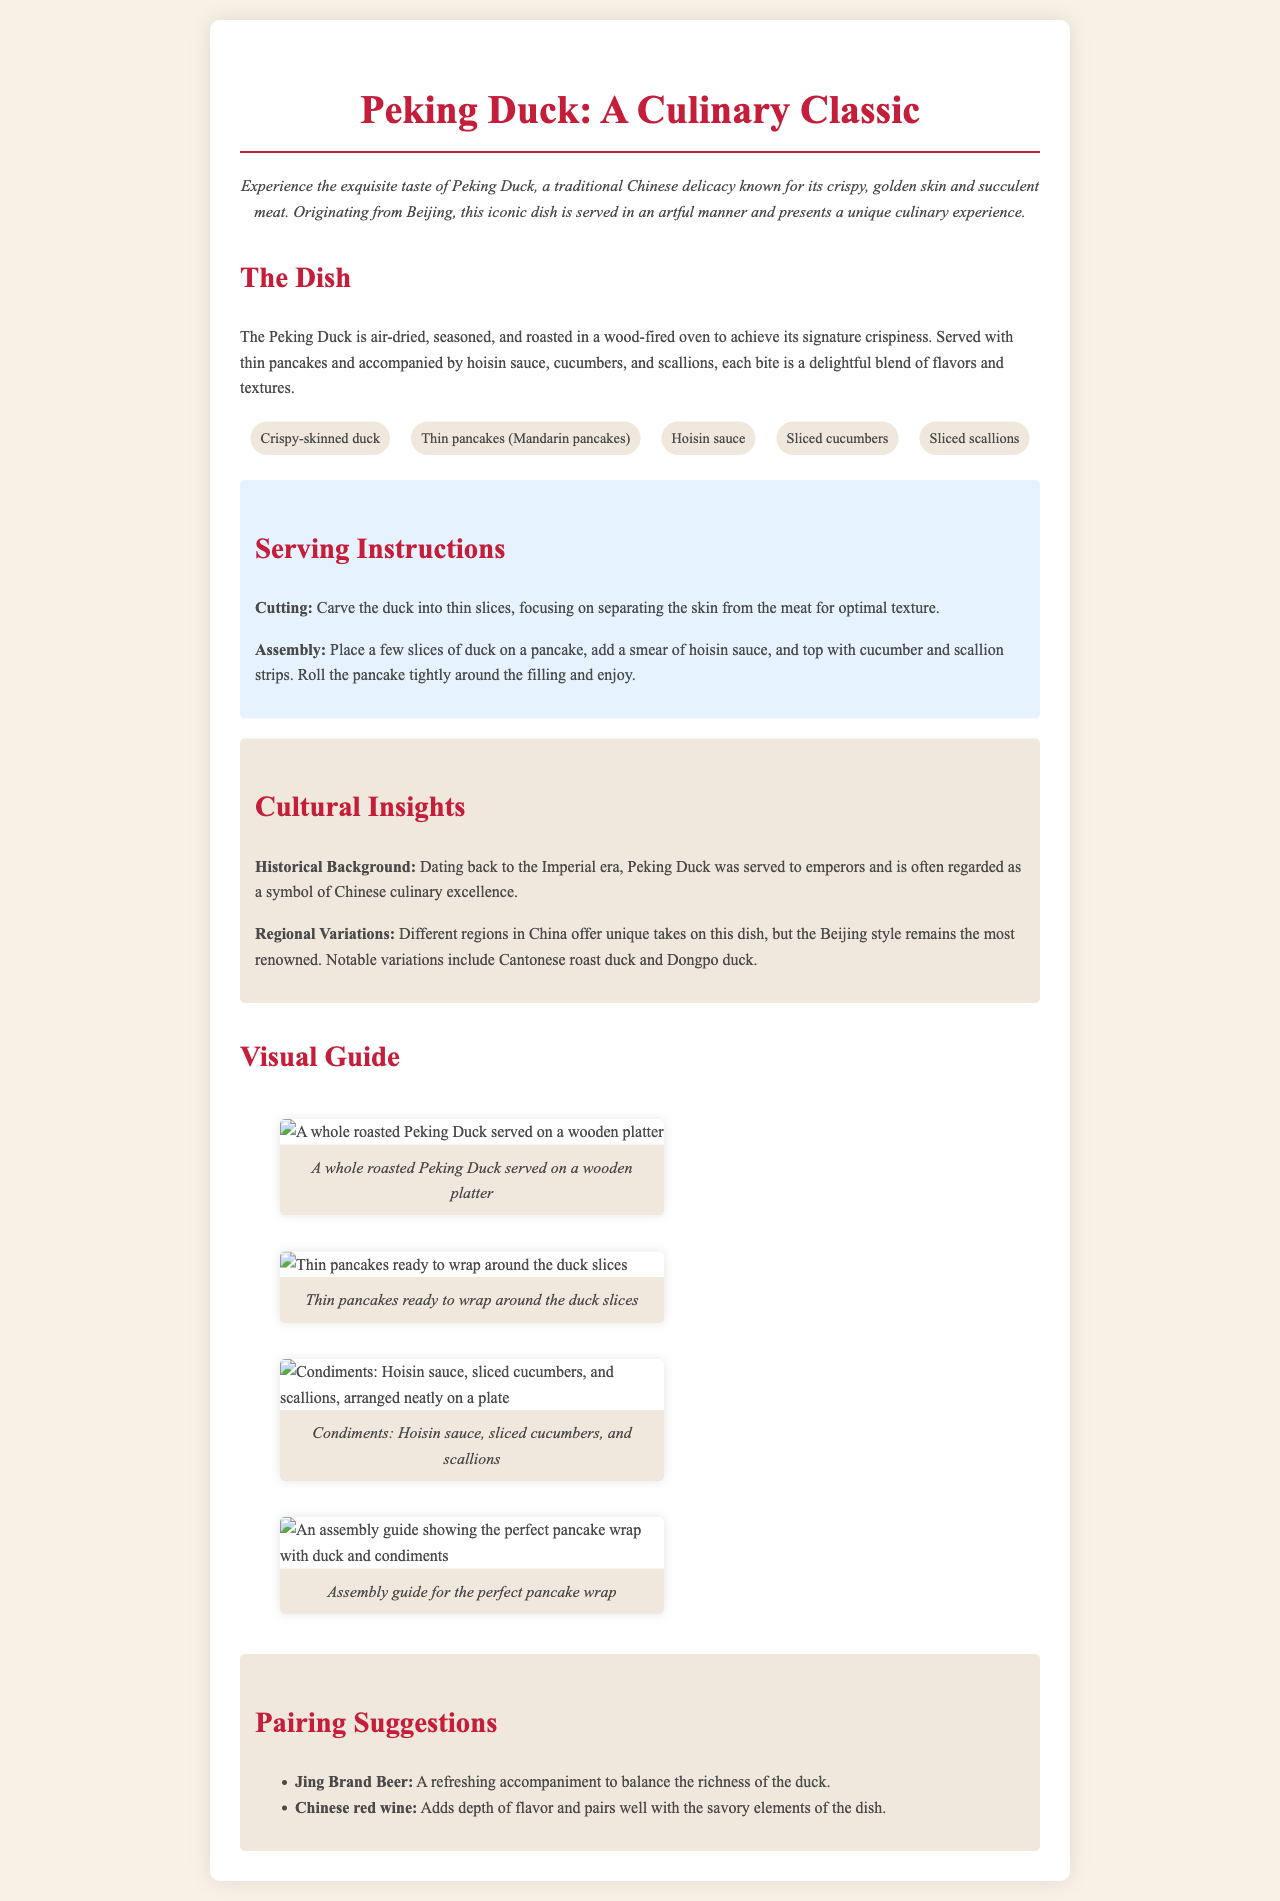What are the key ingredients of Peking Duck? The key ingredients are listed in the document under the section "key-ingredients".
Answer: Crispy-skinned duck, thin pancakes (Mandarin pancakes), hoisin sauce, sliced cucumbers, sliced scallions What is the serving style of Peking Duck? The serving style involves details given in the "Serving Instructions" section.
Answer: On a pancake with hoisin sauce, cucumber, and scallions When did Peking Duck originate? The historical background mentions the origin of Peking Duck.
Answer: Imperial era What beverage pairs well with Peking Duck according to the menu? The "Pairing Suggestions" section lists appropriate beverages.
Answer: Jing Brand Beer How should the duck be cut? The cutting method is described in the "Serving Instructions" section.
Answer: Into thin slices What is the main cooking method for Peking Duck? The cooking method is described in the section titled "The Dish."
Answer: Roasted in a wood-fired oven What is the purpose of the assembly guide image? The assembly guide image shows how to properly assemble the dish.
Answer: Perfect pancake wrap Which region is known for the classic style of Peking Duck? The "Cultural Insights" section mentions the most renowned region for Peking Duck.
Answer: Beijing 